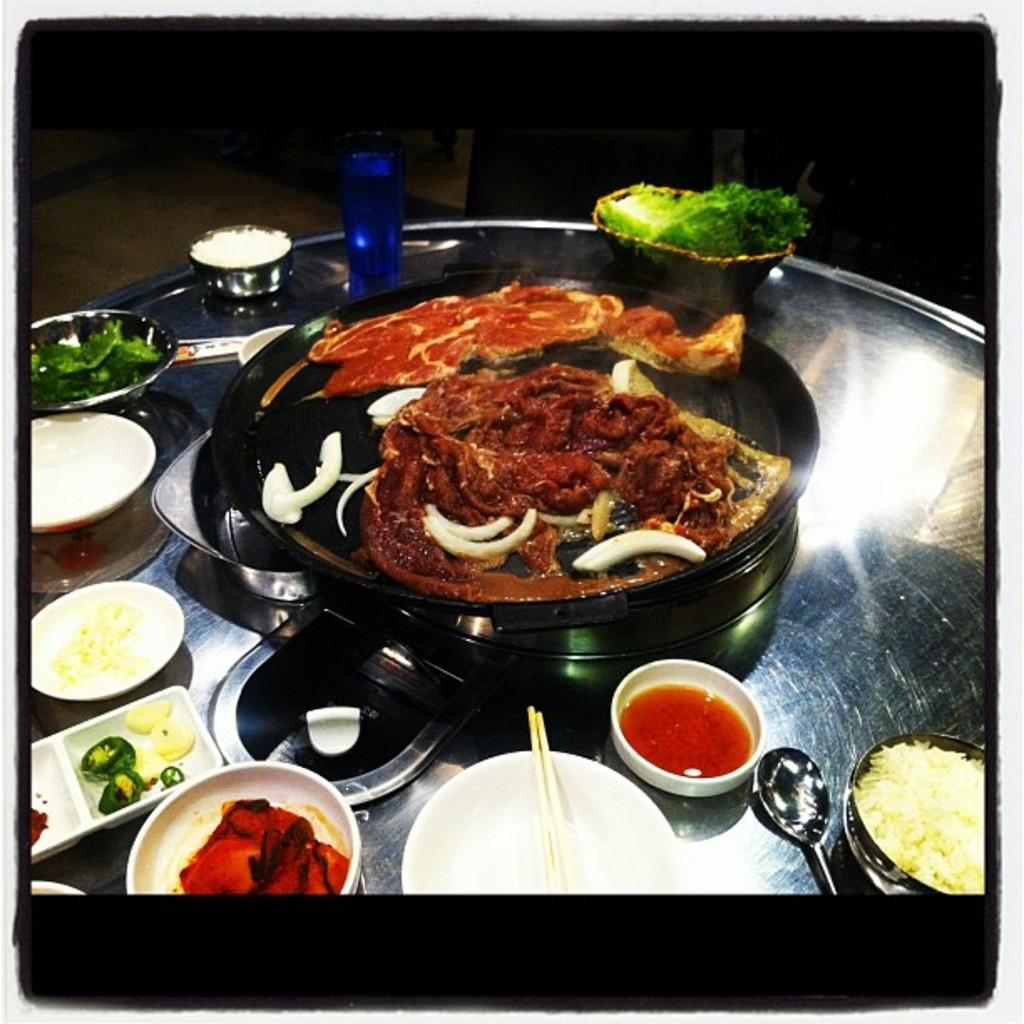What is present in the containers that are visible in the image? There is food in the containers in the image. What month is depicted in the image? There is no month depicted in the image; it features food in containers. What type of house is shown in the image? There is no house shown in the image; it features food in containers. 